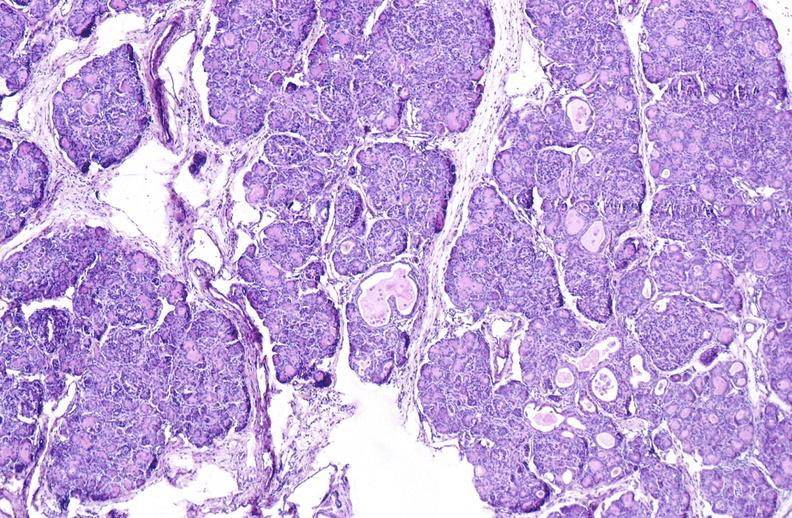where is this?
Answer the question using a single word or phrase. Pancreas 